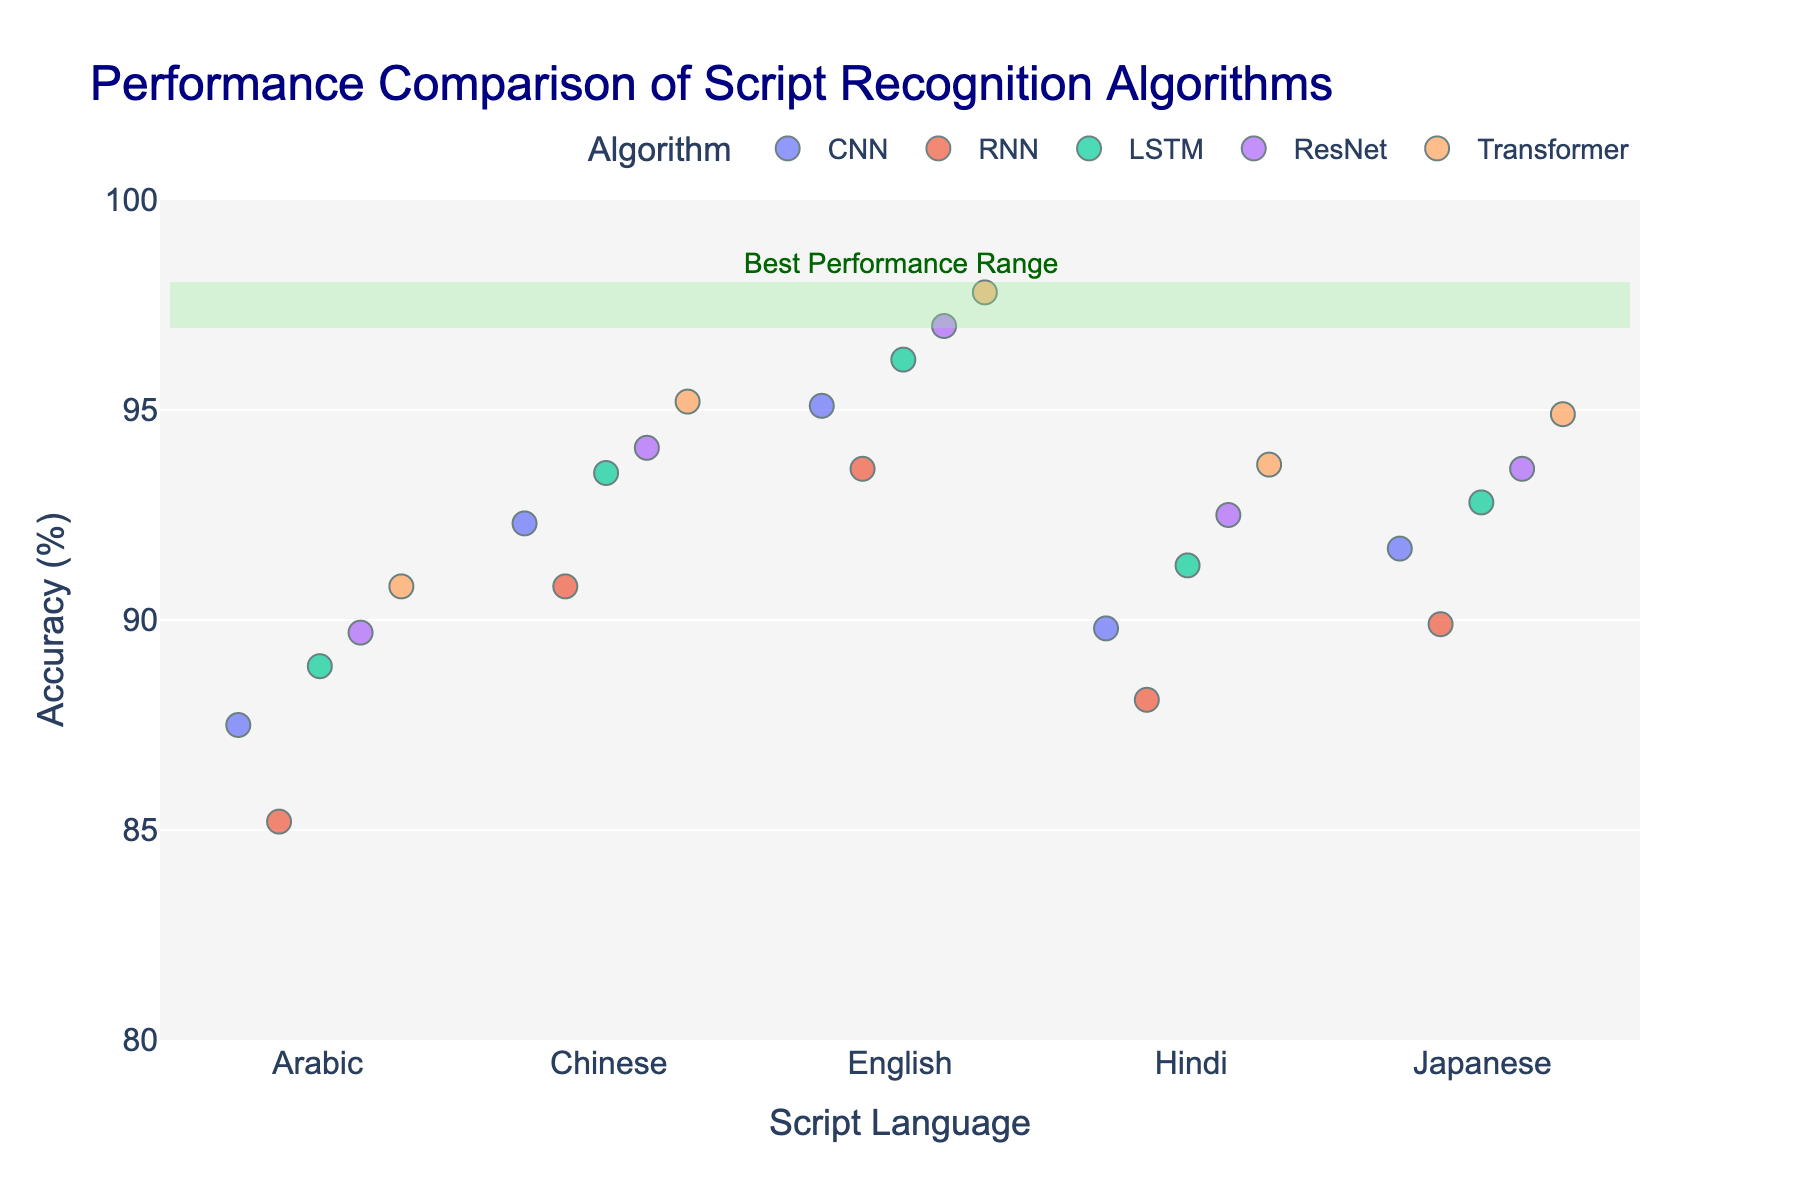What is the title of the plot? The title is usually placed at the top of the plot and directly describes the main focus of the figure.
Answer: Performance Comparison of Script Recognition Algorithms Which language has the highest accuracy for the Transformer algorithm? Identify the highest point associated with the Transformer algorithm (indicated by a particular color) and find the language label corresponding to that point.
Answer: English How many algorithms are compared in the plot? Count the unique color-coded categories in the legend that represent different algorithms used.
Answer: 5 Which algorithm has the lowest accuracy for Arabic script? Look at the data points for Arabic script and compare the accuracy values for each algorithm.
Answer: RNN What is the range of the accuracy values overall? Identify the minimum and maximum values along the y-axis of the plot to determine the range.
Answer: 85.2 - 97.8 Which language shows the largest range of accuracies for different algorithms? Compare the spread of accuracy values for each language by observing the vertical spread of points grouped by language.
Answer: Japanese What is the average accuracy of the RNN algorithm across all languages? Sum the accuracy values for the RNN algorithm and divide by the number of languages (5). Calculation: (85.2 + 90.8 + 93.6 + 88.1 + 89.9) / 5
Answer: 89.52 How does the accuracy of the Transformer algorithm for Hindi script compare to the same for Japanese script? Locate the points for the Transformer algorithm corresponding to Hindi and Japanese and compare their values.
Answer: Hindi is higher than Japanese Which language has the smallest variability in accuracy across different algorithms? Observe and compare the spread (difference between maximum and minimum) of accuracy points for each language.
Answer: Chinese What is the median accuracy of the CNN algorithm? List out the accuracy values of CNN algorithm in increasing order and find the middle value. List: 87.5, 89.8, 91.7, 92.3, 95.1; Median value is 91.7
Answer: 91.7 